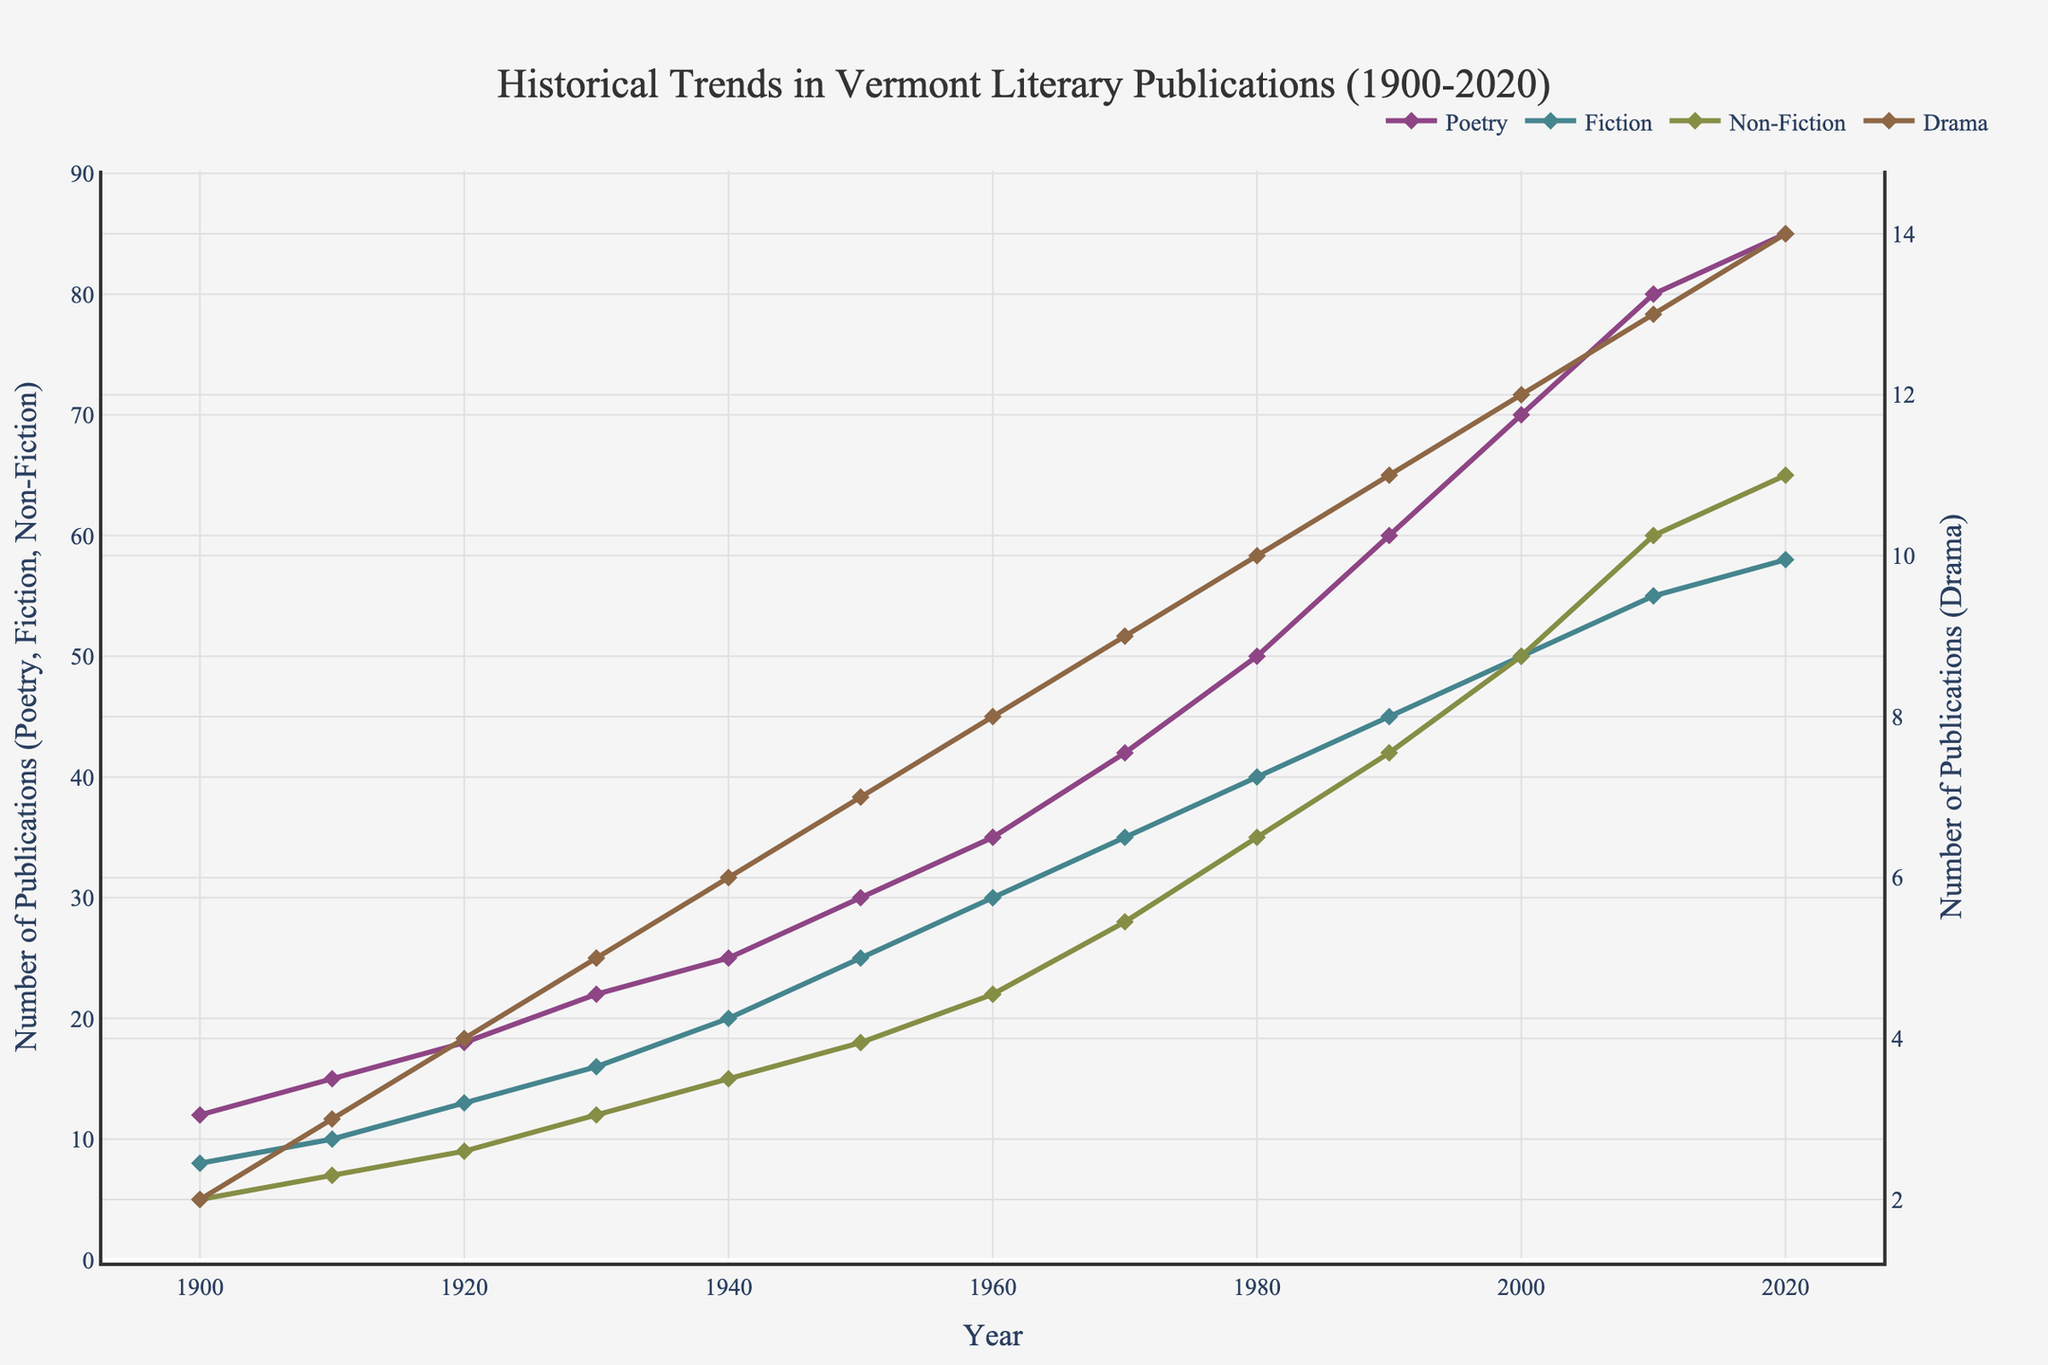What genre had the highest number of publications in 2020? By 2020, the line for Poetry reaches the highest point on the y-axis compared to the lines for Fiction, Non-Fiction, and Drama.
Answer: Poetry Which genre had more significant growth from 1900 to 2020, Poetry or Fiction? Poetry started with 12 publications in 1900 and reached 85 in 2020, while Fiction started with 8 publications in 1900 and reached 58 in 2020. The increase for Poetry is 85 - 12 = 73, and for Fiction, it's 58 - 8 = 50.
Answer: Poetry What is the total number of Non-Fiction publications by 1950? Sum the Non-Fiction publications from 1900 to 1950: 5 + 7 + 9 + 12 + 15 + 18 = 66.
Answer: 66 How did the number of Drama publications change from 1970 to 2010? In 1970, there were 9 Drama publications, and in 2010, there were 13. The change is 13 - 9 = 4.
Answer: Increased by 4 Which two genres have lines closest to each other between 2000 and 2020? From the figure, the lines for Fiction and Non-Fiction appear very close to each other between 2000 and 2020.
Answer: Fiction and Non-Fiction Which genre shows the most consistent growth over the years? The line representing Poetry shows a steady and consistent increase in the number of publications from 1900 to 2020 without any dips.
Answer: Poetry What is the difference in the number of Fiction and Drama publications in 2010? Fiction had 55 publications in 2010, and Drama had 13. The difference is 55 - 13 = 42.
Answer: 42 How does the number of publications in Poetry compare to Drama in 1940? In 1940, Poetry had 25 publications and Drama had 6. Poetry had 25 - 6 = 19 more publications than Drama.
Answer: Poetry had 19 more publications Between Non-Fiction and Fiction, which had a higher increase in publications from 1960 to 1980? Non-Fiction had 22 publications in 1960 and 35 in 1980, an increase of 35 - 22 = 13. Fiction had 30 publications in 1960 and 40 in 1980, an increase of 40 - 30 = 10.
Answer: Non-Fiction By how much did the total number of publications (all genres combined) increase from 1900 to 2020? Sum the publications for all genres in 1900 and 2020: 1900 (12+8+5+2 = 27) and 2020 (85+58+65+14 = 222). The increase is 222 - 27 = 195.
Answer: 195 